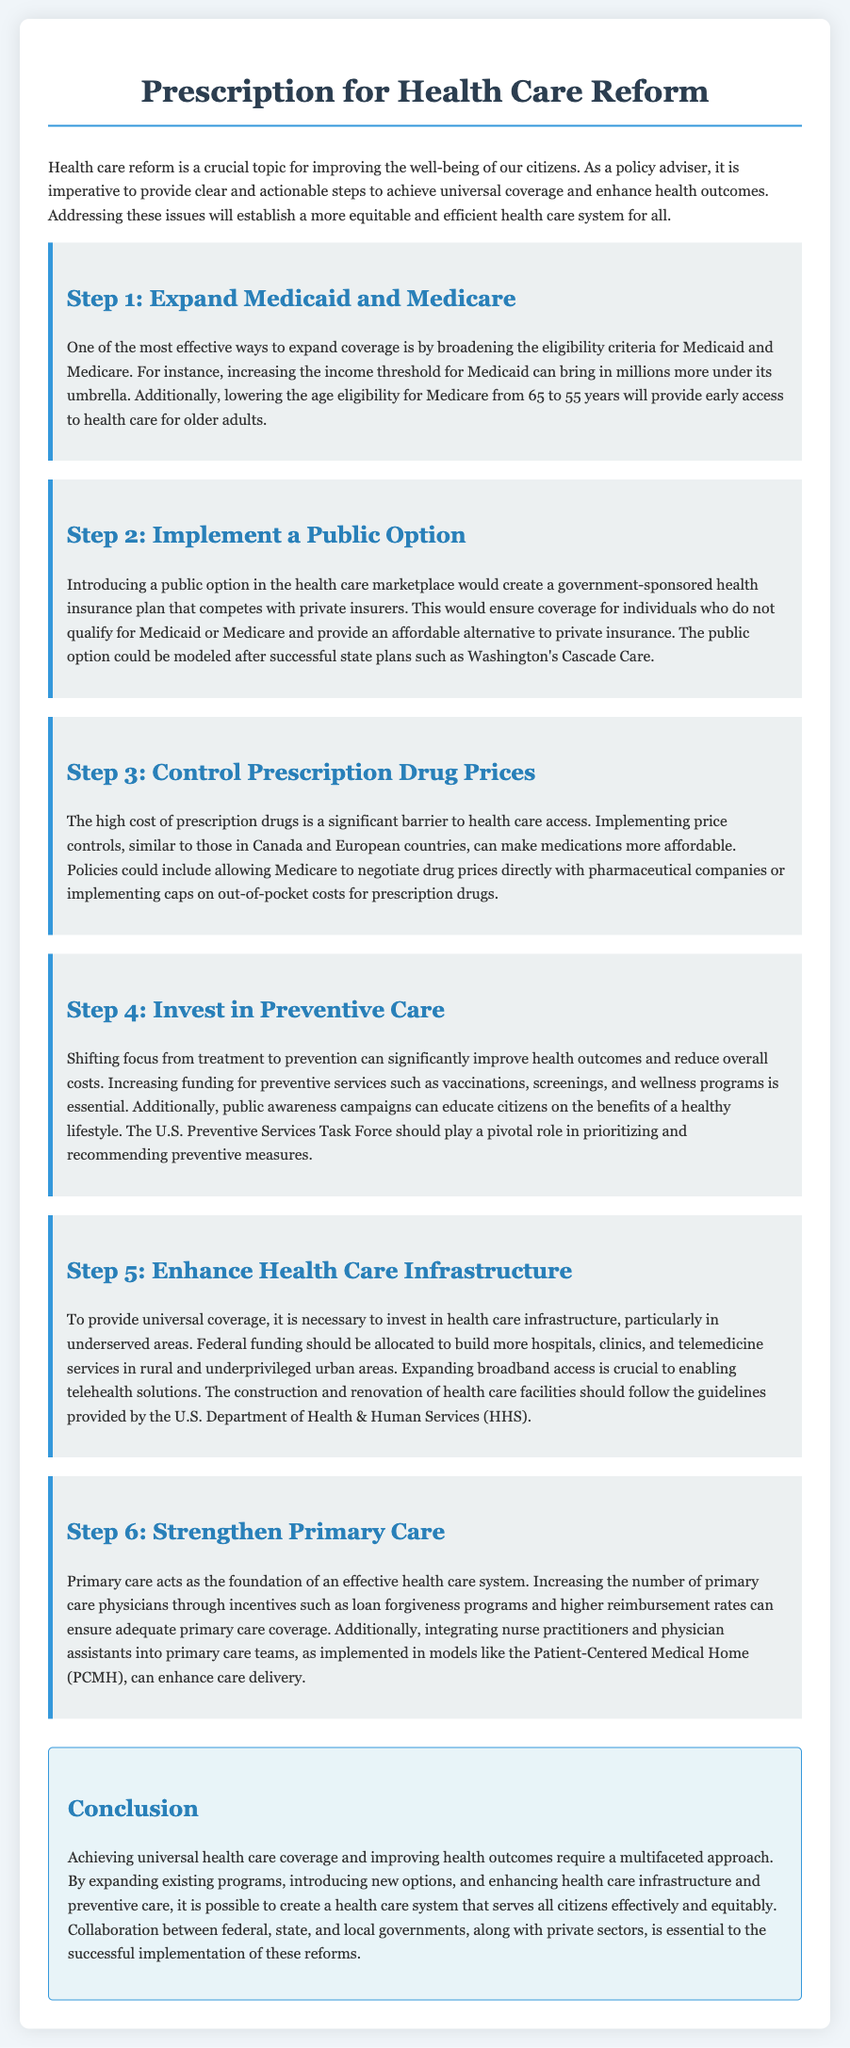What is the first step in the prescription? The document outlines "Step 1: Expand Medicaid and Medicare" as the first step in achieving health care reform.
Answer: Expand Medicaid and Medicare What needs to be implemented to provide an affordable alternative to private insurance? The document states that introducing a public option would create a government-sponsored health insurance plan that competes with private insurers, providing an affordable alternative.
Answer: Public option How can prescription drug prices be controlled? According to the document, implementing price controls similar to those in Canada and European countries can help control prescription drug prices.
Answer: Price controls What does Step 4 focus on? The document indicates that Step 4 emphasizes the importance of shifting focus from treatment to prevention to improve health outcomes.
Answer: Preventive care What is necessary for universal coverage regarding health care infrastructure? The document specifies that investing in health care infrastructure, especially in underserved areas, is necessary for achieving universal coverage.
Answer: Invest in health care infrastructure How does the document suggest to enhance primary care? The document suggests increasing the number of primary care physicians through incentives and integrating nurse practitioners and physician assistants into primary care teams to enhance care delivery.
Answer: Strengthen Primary Care What organization should prioritize and recommend preventive measures? The document mentions the U.S. Preventive Services Task Force as a body that should play a pivotal role in recommending preventive measures.
Answer: U.S. Preventive Services Task Force What is the conclusion of the document regarding health care reform? The conclusion emphasizes that achieving universal health care coverage requires a multifaceted approach through expansion, introduction of options, and improvement of infrastructure.
Answer: Multifaceted approach 